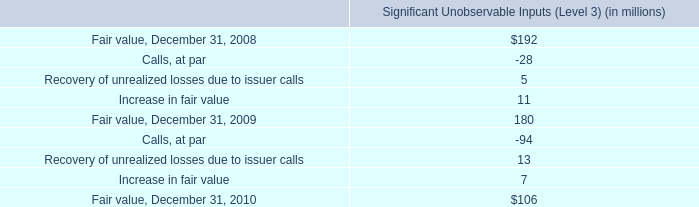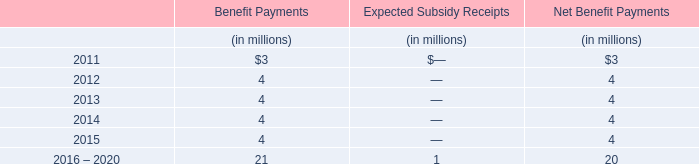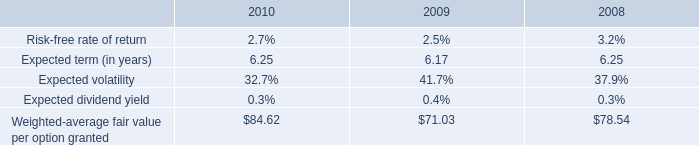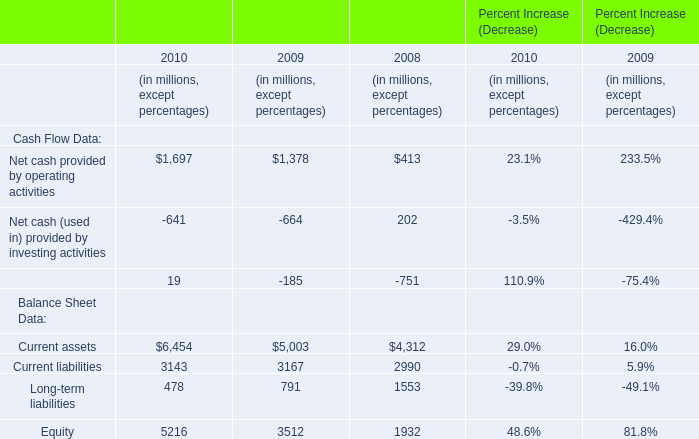what was the percent of the change in the significant unobservable inputs from 2008 to 2009 
Computations: ((180 - 192) / 192)
Answer: -0.0625. 